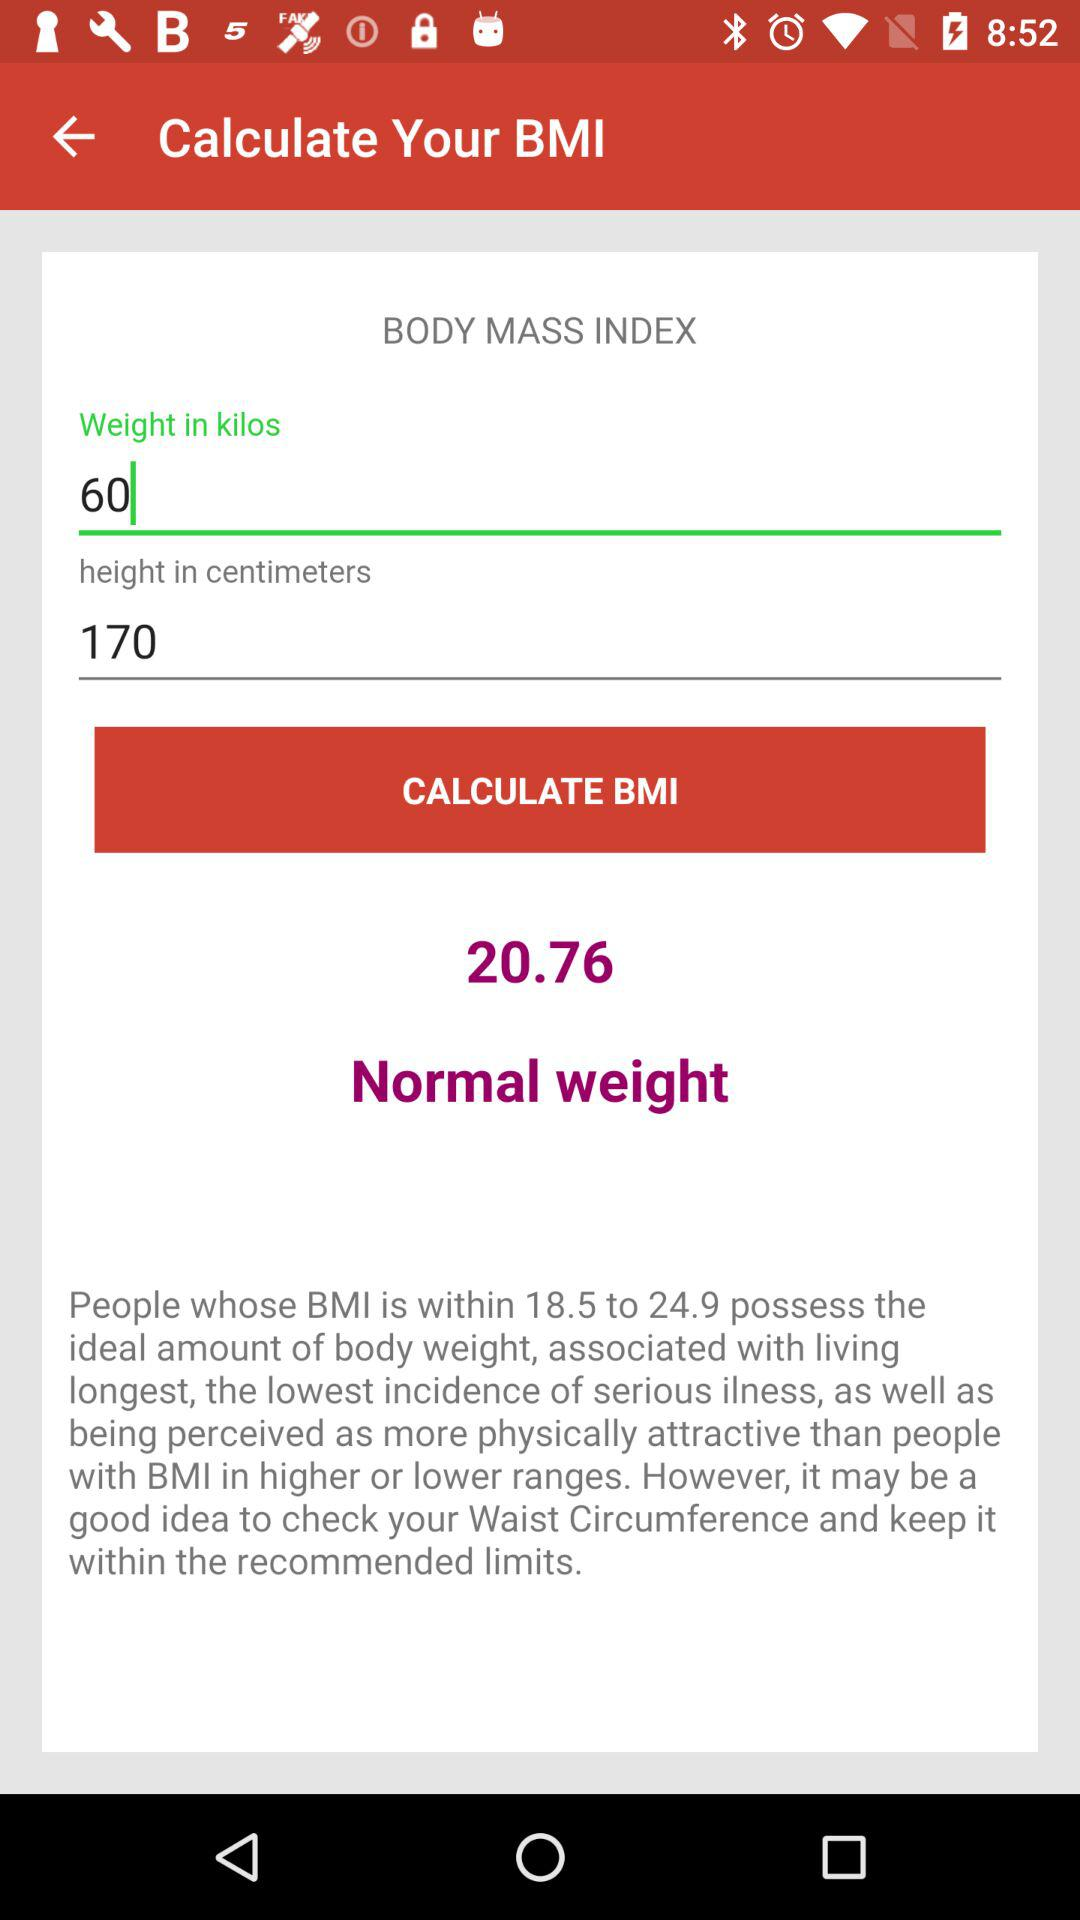What is the unit of height? The unit of height is centimeters. 